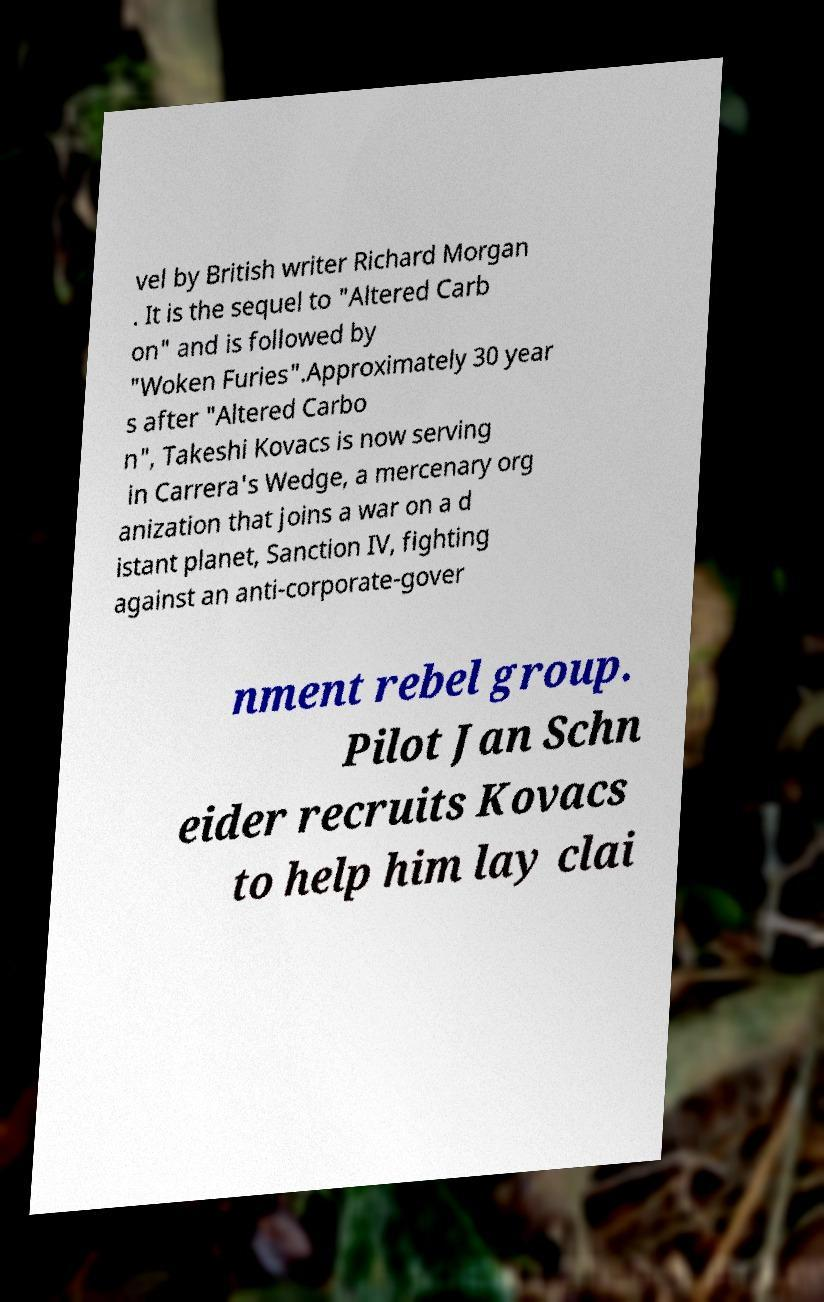For documentation purposes, I need the text within this image transcribed. Could you provide that? vel by British writer Richard Morgan . It is the sequel to "Altered Carb on" and is followed by "Woken Furies".Approximately 30 year s after "Altered Carbo n", Takeshi Kovacs is now serving in Carrera's Wedge, a mercenary org anization that joins a war on a d istant planet, Sanction IV, fighting against an anti-corporate-gover nment rebel group. Pilot Jan Schn eider recruits Kovacs to help him lay clai 